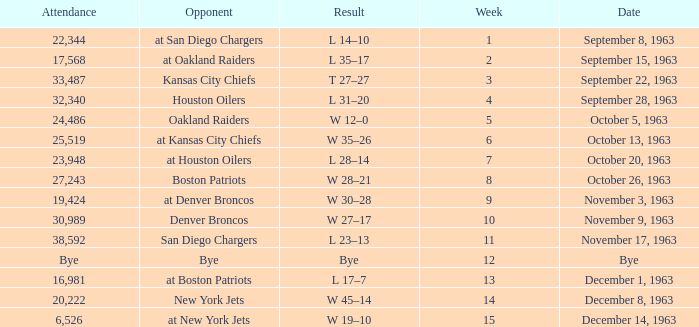Which rival has a result of 14-10? At san diego chargers. Can you parse all the data within this table? {'header': ['Attendance', 'Opponent', 'Result', 'Week', 'Date'], 'rows': [['22,344', 'at San Diego Chargers', 'L 14–10', '1', 'September 8, 1963'], ['17,568', 'at Oakland Raiders', 'L 35–17', '2', 'September 15, 1963'], ['33,487', 'Kansas City Chiefs', 'T 27–27', '3', 'September 22, 1963'], ['32,340', 'Houston Oilers', 'L 31–20', '4', 'September 28, 1963'], ['24,486', 'Oakland Raiders', 'W 12–0', '5', 'October 5, 1963'], ['25,519', 'at Kansas City Chiefs', 'W 35–26', '6', 'October 13, 1963'], ['23,948', 'at Houston Oilers', 'L 28–14', '7', 'October 20, 1963'], ['27,243', 'Boston Patriots', 'W 28–21', '8', 'October 26, 1963'], ['19,424', 'at Denver Broncos', 'W 30–28', '9', 'November 3, 1963'], ['30,989', 'Denver Broncos', 'W 27–17', '10', 'November 9, 1963'], ['38,592', 'San Diego Chargers', 'L 23–13', '11', 'November 17, 1963'], ['Bye', 'Bye', 'Bye', '12', 'Bye'], ['16,981', 'at Boston Patriots', 'L 17–7', '13', 'December 1, 1963'], ['20,222', 'New York Jets', 'W 45–14', '14', 'December 8, 1963'], ['6,526', 'at New York Jets', 'W 19–10', '15', 'December 14, 1963']]} 